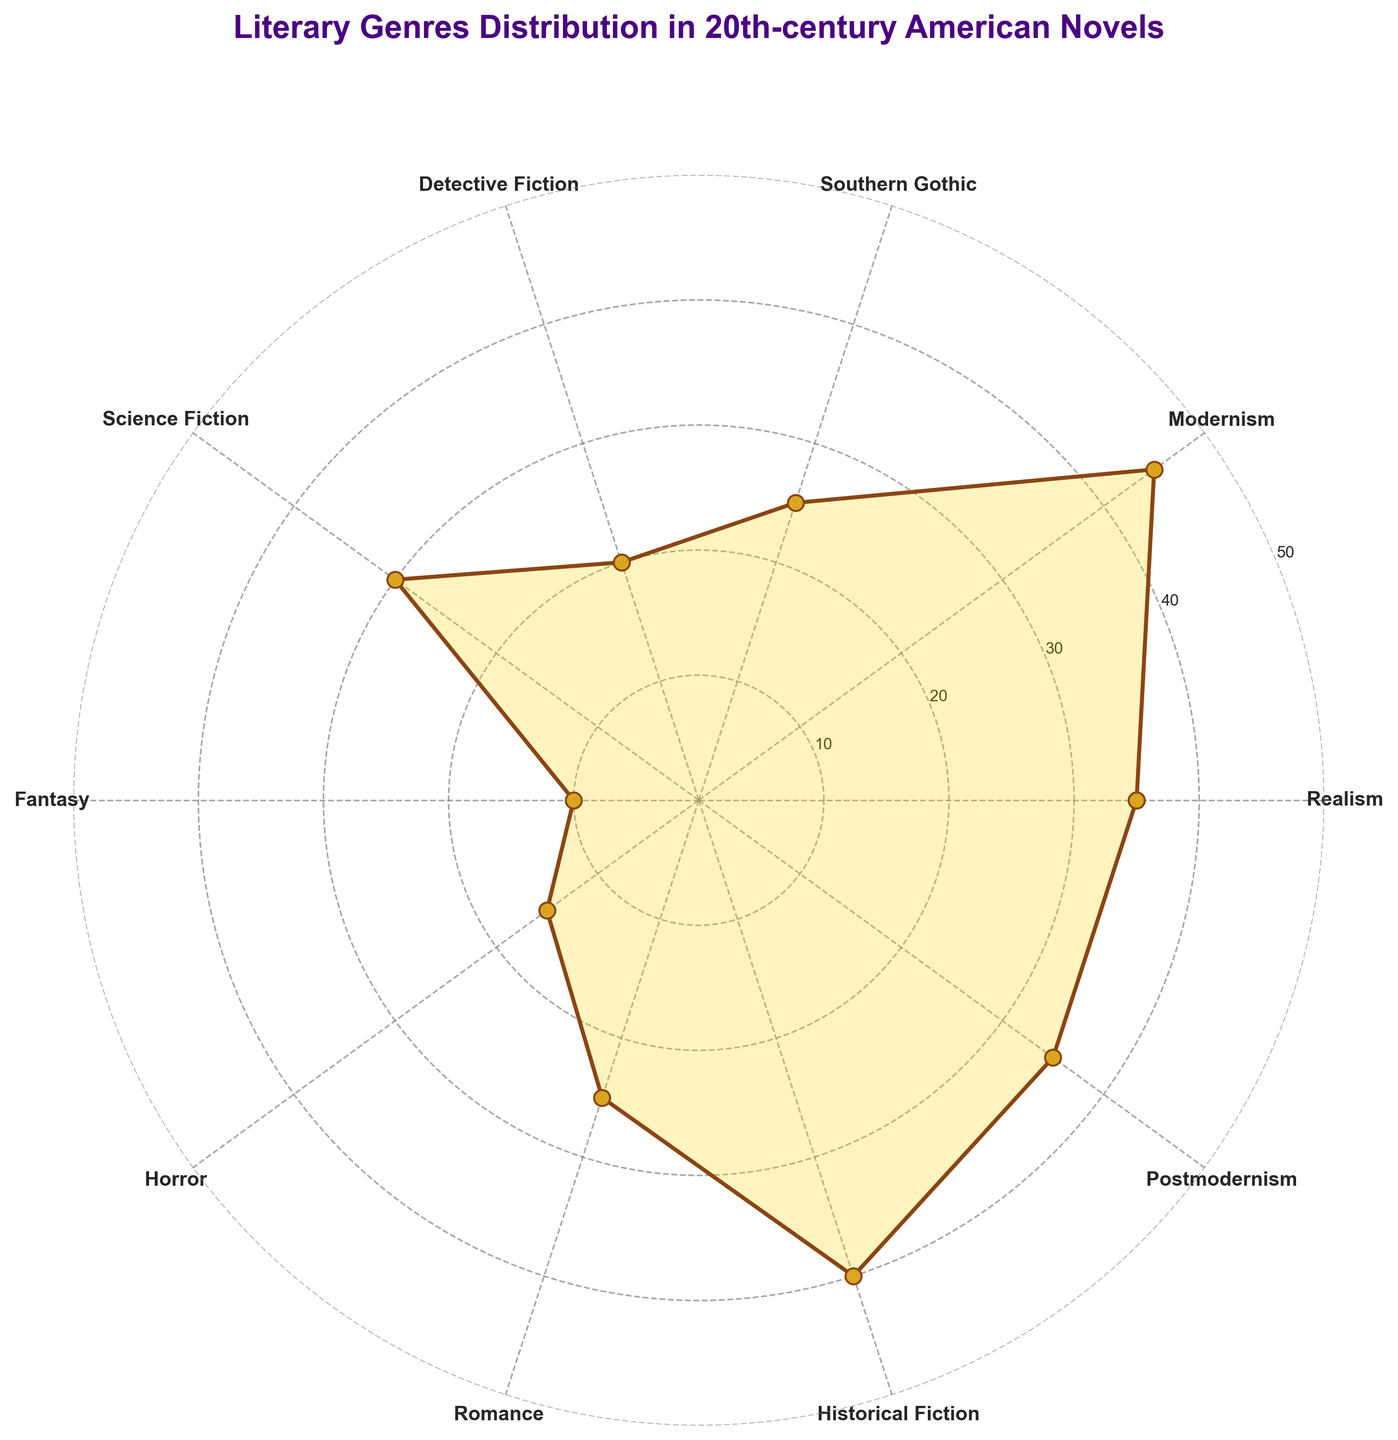What is the title of the figure? The title is usually located at the top of the plot. Here it clearly reads "Literary Genres Distribution in 20th-century American Novels".
Answer: Literary Genres Distribution in 20th-century American Novels How many different literary genres are represented in the polar chart? Each genre is labeled around the circumference of the polar chart. Counting these labels gives us the total number of genres.
Answer: 10 Which literary genre has the highest count? By looking at the radial lines extending outward, the longest line corresponds to the genre with the highest count. Here, it's "Modernism" which extends to 45.
Answer: Modernism What is the count of Science Fiction novels? Locate the label "Science Fiction" on the circumference and trace the radial line associated with it to the inner radial ticks. The count is where this line intersects the radial ticks, which is at 30.
Answer: 30 Which genre has the least count and what is it? The genre with the smallest radial line represents the smallest count. "Fantasy" appears to be the shortest, which is 10.
Answer: Fantasy, 10 How does the count of Historical Fiction compare to Postmodernism? By looking at the radial lines for both "Historical Fiction" and "Postmodernism", Historical Fiction reaches up to 40 while Postmodernism reaches 35, indicating Historical Fiction is greater.
Answer: Historical Fiction has a higher count than Postmodernism What is the total count of Realism and Southern Gothic novels combined? Add the counts of "Realism" (35) and "Southern Gothic" (25). The calculation is 35 + 25.
Answer: 60 What is the average count of Fantasy, Horror, and Romance novels? To find the average, sum the counts of "Fantasy" (10), "Horror" (15), and "Romance" (25) and divide by the number of genres, which is 3. The sum is 10 + 15 + 25 = 50, and the average is 50 / 3.
Answer: ~16.67 Which genres have the same counts? By comparing the radial lines, "Realism" and "Postmodernism" each extend to 35, indicating they have the same counts.
Answer: Realism and Postmodernism How do the genres of Detective Fiction and Romance combined compare to Modernism alone? Add the counts of "Detective Fiction" (20) and "Romance" (25), then compare this sum to "Modernism" (45). The calculation is 20 + 25 = 45, which equals the count for Modernism.
Answer: Equal 